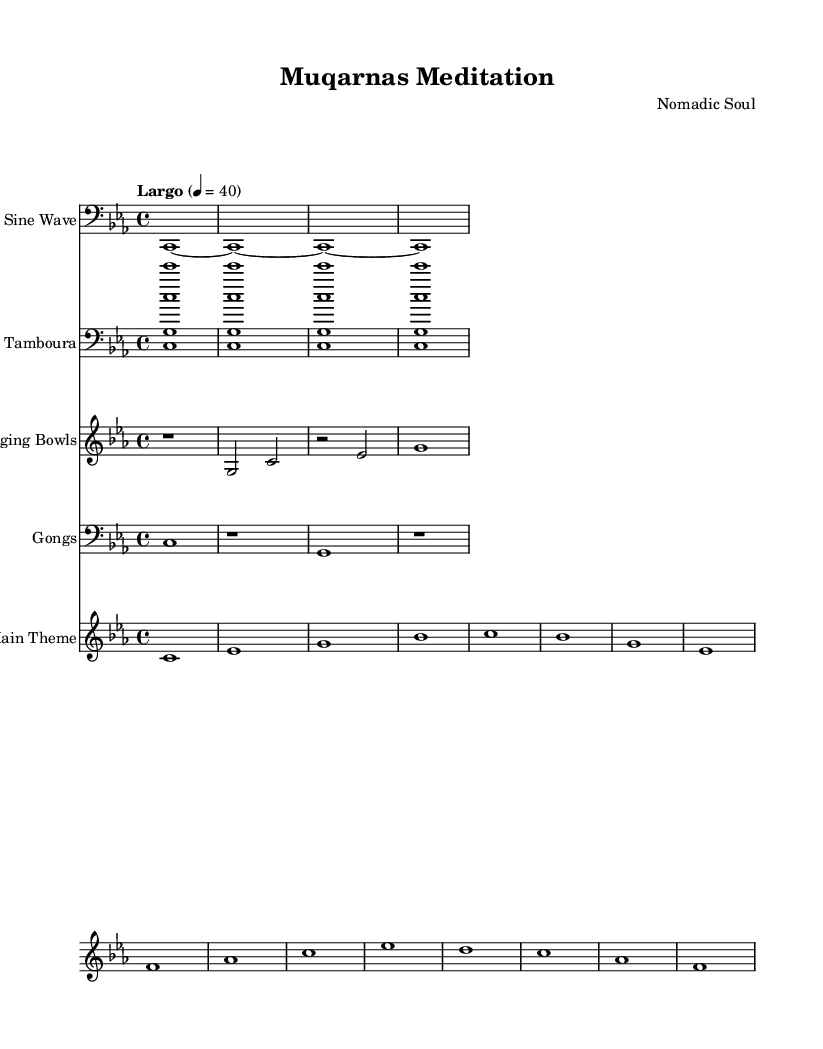What is the key signature of this music? The key signature is C minor, which has three flats: B flat, E flat, and A flat. This can be identified in the key signature area at the beginning of the score.
Answer: C minor What is the time signature of this music? The time signature is indicated as 4/4, which means there are four beats in a measure, and each quarter note receives one beat. This is shown at the beginning of the score.
Answer: 4/4 What is the tempo marking for this piece? The tempo marking is Largo, which indicates a slow pace. This is noted in the tempo section, where it states "Largo" alongside a metronome marking of 40 beats per minute.
Answer: Largo How many instruments are featured in this piece? There are five distinct instruments in the score: Sine Wave, Tamboura, Singing Bowls, Gongs, and Main Theme. This information can be found at the start of each staff that indicates the instrument names.
Answer: Five Which instrument plays the main theme? The Main Theme is played on the specified staff labeled "Main Theme," which is designated with clear notation representing the melody and harmonies aligned with that part.
Answer: Main Theme What rhythmic values are predominantly used in the sine wave part? The sine wave part primarily uses whole notes throughout, as each note is written as a single long duration with no subdivisions indicated. This is evident in the notation seen in the Sine Wave staff.
Answer: Whole notes What kind of sound does the tamboura part evoke in relation to the piece's theme? The tamboura, typically associated with drone music, creates a continuous harmonic support, reflecting the underlying structure of the music, similar to the foundational aspects of Islamic architecture in creating space. This is inferred from the repeating chords in the Tamboura staff.
Answer: Drone 